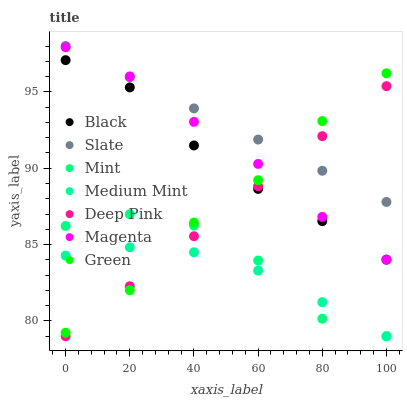Does Medium Mint have the minimum area under the curve?
Answer yes or no. Yes. Does Slate have the maximum area under the curve?
Answer yes or no. Yes. Does Deep Pink have the minimum area under the curve?
Answer yes or no. No. Does Deep Pink have the maximum area under the curve?
Answer yes or no. No. Is Deep Pink the smoothest?
Answer yes or no. Yes. Is Mint the roughest?
Answer yes or no. Yes. Is Slate the smoothest?
Answer yes or no. No. Is Slate the roughest?
Answer yes or no. No. Does Medium Mint have the lowest value?
Answer yes or no. Yes. Does Slate have the lowest value?
Answer yes or no. No. Does Slate have the highest value?
Answer yes or no. Yes. Does Deep Pink have the highest value?
Answer yes or no. No. Is Medium Mint less than Magenta?
Answer yes or no. Yes. Is Slate greater than Medium Mint?
Answer yes or no. Yes. Does Deep Pink intersect Green?
Answer yes or no. Yes. Is Deep Pink less than Green?
Answer yes or no. No. Is Deep Pink greater than Green?
Answer yes or no. No. Does Medium Mint intersect Magenta?
Answer yes or no. No. 